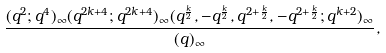Convert formula to latex. <formula><loc_0><loc_0><loc_500><loc_500>\frac { ( q ^ { 2 } ; q ^ { 4 } ) _ { \infty } ( q ^ { 2 k + 4 } ; q ^ { 2 k + 4 } ) _ { \infty } ( q ^ { \frac { k } { 2 } } , - q ^ { \frac { k } { 2 } } , q ^ { 2 + \frac { k } { 2 } } , - q ^ { 2 + \frac { k } { 2 } } ; q ^ { k + 2 } ) _ { \infty } } { ( q ) _ { \infty } } ,</formula> 